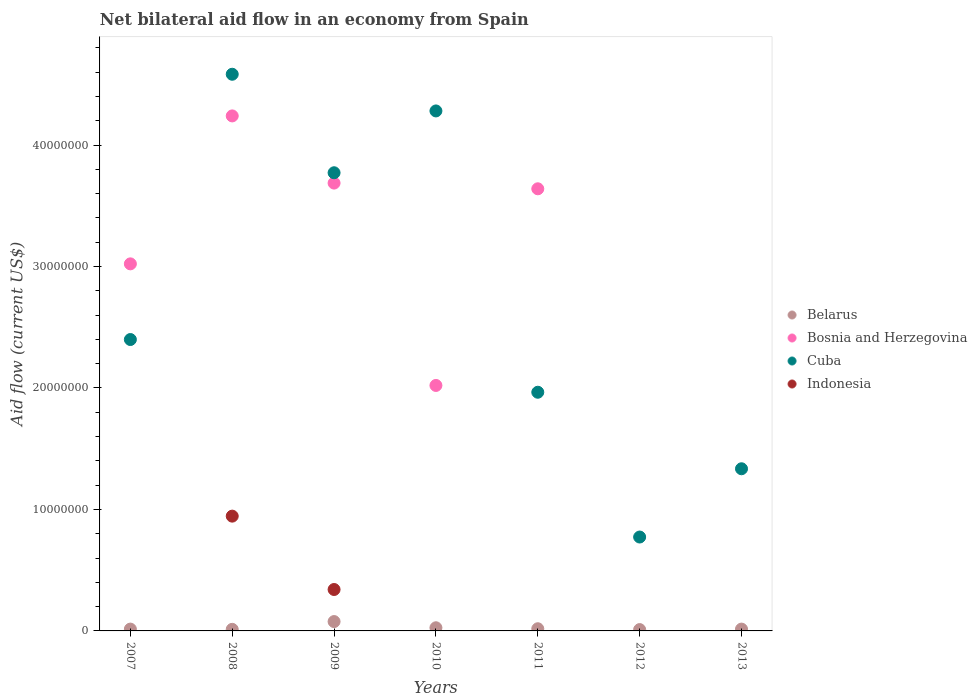Is the number of dotlines equal to the number of legend labels?
Provide a succinct answer. No. What is the net bilateral aid flow in Bosnia and Herzegovina in 2010?
Offer a very short reply. 2.02e+07. Across all years, what is the maximum net bilateral aid flow in Belarus?
Give a very brief answer. 7.70e+05. In which year was the net bilateral aid flow in Bosnia and Herzegovina maximum?
Give a very brief answer. 2008. What is the total net bilateral aid flow in Belarus in the graph?
Provide a succinct answer. 1.75e+06. What is the difference between the net bilateral aid flow in Belarus in 2010 and that in 2011?
Your answer should be compact. 8.00e+04. What is the difference between the net bilateral aid flow in Bosnia and Herzegovina in 2007 and the net bilateral aid flow in Belarus in 2010?
Offer a very short reply. 3.00e+07. What is the average net bilateral aid flow in Indonesia per year?
Your response must be concise. 1.84e+06. In the year 2009, what is the difference between the net bilateral aid flow in Bosnia and Herzegovina and net bilateral aid flow in Belarus?
Offer a very short reply. 3.61e+07. What is the ratio of the net bilateral aid flow in Bosnia and Herzegovina in 2008 to that in 2011?
Your answer should be very brief. 1.16. Is the net bilateral aid flow in Cuba in 2011 less than that in 2013?
Make the answer very short. No. What is the difference between the highest and the second highest net bilateral aid flow in Belarus?
Give a very brief answer. 5.10e+05. What is the difference between the highest and the lowest net bilateral aid flow in Belarus?
Make the answer very short. 6.60e+05. Is it the case that in every year, the sum of the net bilateral aid flow in Indonesia and net bilateral aid flow in Belarus  is greater than the sum of net bilateral aid flow in Bosnia and Herzegovina and net bilateral aid flow in Cuba?
Provide a short and direct response. No. Is it the case that in every year, the sum of the net bilateral aid flow in Belarus and net bilateral aid flow in Cuba  is greater than the net bilateral aid flow in Bosnia and Herzegovina?
Your answer should be compact. No. Is the net bilateral aid flow in Indonesia strictly greater than the net bilateral aid flow in Bosnia and Herzegovina over the years?
Make the answer very short. No. How many dotlines are there?
Keep it short and to the point. 4. How many legend labels are there?
Ensure brevity in your answer.  4. How are the legend labels stacked?
Your answer should be compact. Vertical. What is the title of the graph?
Make the answer very short. Net bilateral aid flow in an economy from Spain. What is the label or title of the X-axis?
Your answer should be very brief. Years. What is the label or title of the Y-axis?
Offer a terse response. Aid flow (current US$). What is the Aid flow (current US$) in Belarus in 2007?
Ensure brevity in your answer.  1.50e+05. What is the Aid flow (current US$) of Bosnia and Herzegovina in 2007?
Provide a succinct answer. 3.02e+07. What is the Aid flow (current US$) in Cuba in 2007?
Provide a short and direct response. 2.40e+07. What is the Aid flow (current US$) of Bosnia and Herzegovina in 2008?
Keep it short and to the point. 4.24e+07. What is the Aid flow (current US$) in Cuba in 2008?
Make the answer very short. 4.58e+07. What is the Aid flow (current US$) of Indonesia in 2008?
Your answer should be very brief. 9.45e+06. What is the Aid flow (current US$) in Belarus in 2009?
Ensure brevity in your answer.  7.70e+05. What is the Aid flow (current US$) in Bosnia and Herzegovina in 2009?
Your answer should be very brief. 3.69e+07. What is the Aid flow (current US$) in Cuba in 2009?
Ensure brevity in your answer.  3.77e+07. What is the Aid flow (current US$) of Indonesia in 2009?
Ensure brevity in your answer.  3.41e+06. What is the Aid flow (current US$) in Belarus in 2010?
Offer a terse response. 2.60e+05. What is the Aid flow (current US$) of Bosnia and Herzegovina in 2010?
Your answer should be compact. 2.02e+07. What is the Aid flow (current US$) of Cuba in 2010?
Your answer should be compact. 4.28e+07. What is the Aid flow (current US$) of Bosnia and Herzegovina in 2011?
Offer a very short reply. 3.64e+07. What is the Aid flow (current US$) in Cuba in 2011?
Offer a terse response. 1.96e+07. What is the Aid flow (current US$) of Belarus in 2012?
Provide a short and direct response. 1.10e+05. What is the Aid flow (current US$) of Cuba in 2012?
Ensure brevity in your answer.  7.73e+06. What is the Aid flow (current US$) in Indonesia in 2012?
Make the answer very short. 0. What is the Aid flow (current US$) of Belarus in 2013?
Provide a short and direct response. 1.50e+05. What is the Aid flow (current US$) in Bosnia and Herzegovina in 2013?
Your response must be concise. 0. What is the Aid flow (current US$) of Cuba in 2013?
Give a very brief answer. 1.34e+07. Across all years, what is the maximum Aid flow (current US$) in Belarus?
Your answer should be very brief. 7.70e+05. Across all years, what is the maximum Aid flow (current US$) of Bosnia and Herzegovina?
Make the answer very short. 4.24e+07. Across all years, what is the maximum Aid flow (current US$) in Cuba?
Provide a short and direct response. 4.58e+07. Across all years, what is the maximum Aid flow (current US$) of Indonesia?
Your answer should be compact. 9.45e+06. Across all years, what is the minimum Aid flow (current US$) of Bosnia and Herzegovina?
Provide a short and direct response. 0. Across all years, what is the minimum Aid flow (current US$) of Cuba?
Make the answer very short. 7.73e+06. Across all years, what is the minimum Aid flow (current US$) of Indonesia?
Ensure brevity in your answer.  0. What is the total Aid flow (current US$) of Belarus in the graph?
Your answer should be very brief. 1.75e+06. What is the total Aid flow (current US$) in Bosnia and Herzegovina in the graph?
Ensure brevity in your answer.  1.66e+08. What is the total Aid flow (current US$) of Cuba in the graph?
Your answer should be compact. 1.91e+08. What is the total Aid flow (current US$) of Indonesia in the graph?
Keep it short and to the point. 1.29e+07. What is the difference between the Aid flow (current US$) of Bosnia and Herzegovina in 2007 and that in 2008?
Give a very brief answer. -1.22e+07. What is the difference between the Aid flow (current US$) in Cuba in 2007 and that in 2008?
Ensure brevity in your answer.  -2.18e+07. What is the difference between the Aid flow (current US$) of Belarus in 2007 and that in 2009?
Make the answer very short. -6.20e+05. What is the difference between the Aid flow (current US$) of Bosnia and Herzegovina in 2007 and that in 2009?
Make the answer very short. -6.65e+06. What is the difference between the Aid flow (current US$) of Cuba in 2007 and that in 2009?
Provide a succinct answer. -1.37e+07. What is the difference between the Aid flow (current US$) of Bosnia and Herzegovina in 2007 and that in 2010?
Provide a short and direct response. 1.00e+07. What is the difference between the Aid flow (current US$) in Cuba in 2007 and that in 2010?
Offer a terse response. -1.88e+07. What is the difference between the Aid flow (current US$) of Bosnia and Herzegovina in 2007 and that in 2011?
Your answer should be compact. -6.18e+06. What is the difference between the Aid flow (current US$) of Cuba in 2007 and that in 2011?
Your answer should be very brief. 4.34e+06. What is the difference between the Aid flow (current US$) in Cuba in 2007 and that in 2012?
Offer a terse response. 1.63e+07. What is the difference between the Aid flow (current US$) of Belarus in 2007 and that in 2013?
Make the answer very short. 0. What is the difference between the Aid flow (current US$) in Cuba in 2007 and that in 2013?
Ensure brevity in your answer.  1.06e+07. What is the difference between the Aid flow (current US$) in Belarus in 2008 and that in 2009?
Offer a terse response. -6.40e+05. What is the difference between the Aid flow (current US$) in Bosnia and Herzegovina in 2008 and that in 2009?
Offer a very short reply. 5.53e+06. What is the difference between the Aid flow (current US$) in Cuba in 2008 and that in 2009?
Your answer should be very brief. 8.11e+06. What is the difference between the Aid flow (current US$) of Indonesia in 2008 and that in 2009?
Offer a terse response. 6.04e+06. What is the difference between the Aid flow (current US$) in Belarus in 2008 and that in 2010?
Offer a terse response. -1.30e+05. What is the difference between the Aid flow (current US$) in Bosnia and Herzegovina in 2008 and that in 2010?
Your answer should be compact. 2.22e+07. What is the difference between the Aid flow (current US$) in Cuba in 2008 and that in 2010?
Your answer should be very brief. 3.02e+06. What is the difference between the Aid flow (current US$) of Cuba in 2008 and that in 2011?
Offer a terse response. 2.62e+07. What is the difference between the Aid flow (current US$) in Belarus in 2008 and that in 2012?
Offer a terse response. 2.00e+04. What is the difference between the Aid flow (current US$) in Cuba in 2008 and that in 2012?
Your answer should be very brief. 3.81e+07. What is the difference between the Aid flow (current US$) of Cuba in 2008 and that in 2013?
Offer a terse response. 3.25e+07. What is the difference between the Aid flow (current US$) of Belarus in 2009 and that in 2010?
Provide a succinct answer. 5.10e+05. What is the difference between the Aid flow (current US$) of Bosnia and Herzegovina in 2009 and that in 2010?
Offer a terse response. 1.67e+07. What is the difference between the Aid flow (current US$) in Cuba in 2009 and that in 2010?
Make the answer very short. -5.09e+06. What is the difference between the Aid flow (current US$) in Belarus in 2009 and that in 2011?
Ensure brevity in your answer.  5.90e+05. What is the difference between the Aid flow (current US$) in Bosnia and Herzegovina in 2009 and that in 2011?
Your answer should be very brief. 4.70e+05. What is the difference between the Aid flow (current US$) in Cuba in 2009 and that in 2011?
Offer a terse response. 1.81e+07. What is the difference between the Aid flow (current US$) in Belarus in 2009 and that in 2012?
Keep it short and to the point. 6.60e+05. What is the difference between the Aid flow (current US$) in Cuba in 2009 and that in 2012?
Give a very brief answer. 3.00e+07. What is the difference between the Aid flow (current US$) of Belarus in 2009 and that in 2013?
Offer a very short reply. 6.20e+05. What is the difference between the Aid flow (current US$) of Cuba in 2009 and that in 2013?
Make the answer very short. 2.44e+07. What is the difference between the Aid flow (current US$) in Belarus in 2010 and that in 2011?
Give a very brief answer. 8.00e+04. What is the difference between the Aid flow (current US$) of Bosnia and Herzegovina in 2010 and that in 2011?
Provide a succinct answer. -1.62e+07. What is the difference between the Aid flow (current US$) of Cuba in 2010 and that in 2011?
Keep it short and to the point. 2.32e+07. What is the difference between the Aid flow (current US$) in Belarus in 2010 and that in 2012?
Make the answer very short. 1.50e+05. What is the difference between the Aid flow (current US$) in Cuba in 2010 and that in 2012?
Make the answer very short. 3.51e+07. What is the difference between the Aid flow (current US$) of Cuba in 2010 and that in 2013?
Give a very brief answer. 2.95e+07. What is the difference between the Aid flow (current US$) in Belarus in 2011 and that in 2012?
Your response must be concise. 7.00e+04. What is the difference between the Aid flow (current US$) of Cuba in 2011 and that in 2012?
Offer a very short reply. 1.19e+07. What is the difference between the Aid flow (current US$) in Belarus in 2011 and that in 2013?
Provide a succinct answer. 3.00e+04. What is the difference between the Aid flow (current US$) in Cuba in 2011 and that in 2013?
Keep it short and to the point. 6.30e+06. What is the difference between the Aid flow (current US$) of Belarus in 2012 and that in 2013?
Offer a terse response. -4.00e+04. What is the difference between the Aid flow (current US$) in Cuba in 2012 and that in 2013?
Your answer should be very brief. -5.62e+06. What is the difference between the Aid flow (current US$) of Belarus in 2007 and the Aid flow (current US$) of Bosnia and Herzegovina in 2008?
Ensure brevity in your answer.  -4.22e+07. What is the difference between the Aid flow (current US$) of Belarus in 2007 and the Aid flow (current US$) of Cuba in 2008?
Ensure brevity in your answer.  -4.57e+07. What is the difference between the Aid flow (current US$) in Belarus in 2007 and the Aid flow (current US$) in Indonesia in 2008?
Your answer should be very brief. -9.30e+06. What is the difference between the Aid flow (current US$) in Bosnia and Herzegovina in 2007 and the Aid flow (current US$) in Cuba in 2008?
Your answer should be very brief. -1.56e+07. What is the difference between the Aid flow (current US$) of Bosnia and Herzegovina in 2007 and the Aid flow (current US$) of Indonesia in 2008?
Ensure brevity in your answer.  2.08e+07. What is the difference between the Aid flow (current US$) in Cuba in 2007 and the Aid flow (current US$) in Indonesia in 2008?
Your answer should be compact. 1.45e+07. What is the difference between the Aid flow (current US$) of Belarus in 2007 and the Aid flow (current US$) of Bosnia and Herzegovina in 2009?
Provide a succinct answer. -3.67e+07. What is the difference between the Aid flow (current US$) of Belarus in 2007 and the Aid flow (current US$) of Cuba in 2009?
Offer a very short reply. -3.76e+07. What is the difference between the Aid flow (current US$) in Belarus in 2007 and the Aid flow (current US$) in Indonesia in 2009?
Your answer should be very brief. -3.26e+06. What is the difference between the Aid flow (current US$) in Bosnia and Herzegovina in 2007 and the Aid flow (current US$) in Cuba in 2009?
Your answer should be very brief. -7.50e+06. What is the difference between the Aid flow (current US$) in Bosnia and Herzegovina in 2007 and the Aid flow (current US$) in Indonesia in 2009?
Offer a terse response. 2.68e+07. What is the difference between the Aid flow (current US$) of Cuba in 2007 and the Aid flow (current US$) of Indonesia in 2009?
Provide a short and direct response. 2.06e+07. What is the difference between the Aid flow (current US$) of Belarus in 2007 and the Aid flow (current US$) of Bosnia and Herzegovina in 2010?
Provide a short and direct response. -2.01e+07. What is the difference between the Aid flow (current US$) in Belarus in 2007 and the Aid flow (current US$) in Cuba in 2010?
Make the answer very short. -4.27e+07. What is the difference between the Aid flow (current US$) in Bosnia and Herzegovina in 2007 and the Aid flow (current US$) in Cuba in 2010?
Give a very brief answer. -1.26e+07. What is the difference between the Aid flow (current US$) of Belarus in 2007 and the Aid flow (current US$) of Bosnia and Herzegovina in 2011?
Make the answer very short. -3.62e+07. What is the difference between the Aid flow (current US$) of Belarus in 2007 and the Aid flow (current US$) of Cuba in 2011?
Give a very brief answer. -1.95e+07. What is the difference between the Aid flow (current US$) of Bosnia and Herzegovina in 2007 and the Aid flow (current US$) of Cuba in 2011?
Offer a terse response. 1.06e+07. What is the difference between the Aid flow (current US$) in Belarus in 2007 and the Aid flow (current US$) in Cuba in 2012?
Offer a very short reply. -7.58e+06. What is the difference between the Aid flow (current US$) of Bosnia and Herzegovina in 2007 and the Aid flow (current US$) of Cuba in 2012?
Provide a short and direct response. 2.25e+07. What is the difference between the Aid flow (current US$) of Belarus in 2007 and the Aid flow (current US$) of Cuba in 2013?
Offer a very short reply. -1.32e+07. What is the difference between the Aid flow (current US$) of Bosnia and Herzegovina in 2007 and the Aid flow (current US$) of Cuba in 2013?
Your answer should be very brief. 1.69e+07. What is the difference between the Aid flow (current US$) of Belarus in 2008 and the Aid flow (current US$) of Bosnia and Herzegovina in 2009?
Make the answer very short. -3.67e+07. What is the difference between the Aid flow (current US$) in Belarus in 2008 and the Aid flow (current US$) in Cuba in 2009?
Offer a terse response. -3.76e+07. What is the difference between the Aid flow (current US$) in Belarus in 2008 and the Aid flow (current US$) in Indonesia in 2009?
Provide a succinct answer. -3.28e+06. What is the difference between the Aid flow (current US$) of Bosnia and Herzegovina in 2008 and the Aid flow (current US$) of Cuba in 2009?
Provide a succinct answer. 4.68e+06. What is the difference between the Aid flow (current US$) in Bosnia and Herzegovina in 2008 and the Aid flow (current US$) in Indonesia in 2009?
Offer a very short reply. 3.90e+07. What is the difference between the Aid flow (current US$) of Cuba in 2008 and the Aid flow (current US$) of Indonesia in 2009?
Give a very brief answer. 4.24e+07. What is the difference between the Aid flow (current US$) of Belarus in 2008 and the Aid flow (current US$) of Bosnia and Herzegovina in 2010?
Your answer should be compact. -2.01e+07. What is the difference between the Aid flow (current US$) of Belarus in 2008 and the Aid flow (current US$) of Cuba in 2010?
Offer a terse response. -4.27e+07. What is the difference between the Aid flow (current US$) in Bosnia and Herzegovina in 2008 and the Aid flow (current US$) in Cuba in 2010?
Provide a succinct answer. -4.10e+05. What is the difference between the Aid flow (current US$) in Belarus in 2008 and the Aid flow (current US$) in Bosnia and Herzegovina in 2011?
Offer a terse response. -3.63e+07. What is the difference between the Aid flow (current US$) of Belarus in 2008 and the Aid flow (current US$) of Cuba in 2011?
Offer a terse response. -1.95e+07. What is the difference between the Aid flow (current US$) of Bosnia and Herzegovina in 2008 and the Aid flow (current US$) of Cuba in 2011?
Ensure brevity in your answer.  2.28e+07. What is the difference between the Aid flow (current US$) in Belarus in 2008 and the Aid flow (current US$) in Cuba in 2012?
Offer a terse response. -7.60e+06. What is the difference between the Aid flow (current US$) of Bosnia and Herzegovina in 2008 and the Aid flow (current US$) of Cuba in 2012?
Make the answer very short. 3.47e+07. What is the difference between the Aid flow (current US$) of Belarus in 2008 and the Aid flow (current US$) of Cuba in 2013?
Offer a terse response. -1.32e+07. What is the difference between the Aid flow (current US$) in Bosnia and Herzegovina in 2008 and the Aid flow (current US$) in Cuba in 2013?
Ensure brevity in your answer.  2.90e+07. What is the difference between the Aid flow (current US$) of Belarus in 2009 and the Aid flow (current US$) of Bosnia and Herzegovina in 2010?
Your response must be concise. -1.94e+07. What is the difference between the Aid flow (current US$) of Belarus in 2009 and the Aid flow (current US$) of Cuba in 2010?
Your answer should be compact. -4.20e+07. What is the difference between the Aid flow (current US$) in Bosnia and Herzegovina in 2009 and the Aid flow (current US$) in Cuba in 2010?
Make the answer very short. -5.94e+06. What is the difference between the Aid flow (current US$) in Belarus in 2009 and the Aid flow (current US$) in Bosnia and Herzegovina in 2011?
Your response must be concise. -3.56e+07. What is the difference between the Aid flow (current US$) in Belarus in 2009 and the Aid flow (current US$) in Cuba in 2011?
Provide a succinct answer. -1.89e+07. What is the difference between the Aid flow (current US$) of Bosnia and Herzegovina in 2009 and the Aid flow (current US$) of Cuba in 2011?
Give a very brief answer. 1.72e+07. What is the difference between the Aid flow (current US$) of Belarus in 2009 and the Aid flow (current US$) of Cuba in 2012?
Your answer should be compact. -6.96e+06. What is the difference between the Aid flow (current US$) of Bosnia and Herzegovina in 2009 and the Aid flow (current US$) of Cuba in 2012?
Ensure brevity in your answer.  2.91e+07. What is the difference between the Aid flow (current US$) of Belarus in 2009 and the Aid flow (current US$) of Cuba in 2013?
Provide a short and direct response. -1.26e+07. What is the difference between the Aid flow (current US$) in Bosnia and Herzegovina in 2009 and the Aid flow (current US$) in Cuba in 2013?
Keep it short and to the point. 2.35e+07. What is the difference between the Aid flow (current US$) of Belarus in 2010 and the Aid flow (current US$) of Bosnia and Herzegovina in 2011?
Ensure brevity in your answer.  -3.61e+07. What is the difference between the Aid flow (current US$) in Belarus in 2010 and the Aid flow (current US$) in Cuba in 2011?
Your response must be concise. -1.94e+07. What is the difference between the Aid flow (current US$) of Bosnia and Herzegovina in 2010 and the Aid flow (current US$) of Cuba in 2011?
Keep it short and to the point. 5.60e+05. What is the difference between the Aid flow (current US$) in Belarus in 2010 and the Aid flow (current US$) in Cuba in 2012?
Your answer should be very brief. -7.47e+06. What is the difference between the Aid flow (current US$) in Bosnia and Herzegovina in 2010 and the Aid flow (current US$) in Cuba in 2012?
Provide a succinct answer. 1.25e+07. What is the difference between the Aid flow (current US$) in Belarus in 2010 and the Aid flow (current US$) in Cuba in 2013?
Your response must be concise. -1.31e+07. What is the difference between the Aid flow (current US$) in Bosnia and Herzegovina in 2010 and the Aid flow (current US$) in Cuba in 2013?
Your answer should be very brief. 6.86e+06. What is the difference between the Aid flow (current US$) of Belarus in 2011 and the Aid flow (current US$) of Cuba in 2012?
Ensure brevity in your answer.  -7.55e+06. What is the difference between the Aid flow (current US$) in Bosnia and Herzegovina in 2011 and the Aid flow (current US$) in Cuba in 2012?
Offer a terse response. 2.87e+07. What is the difference between the Aid flow (current US$) in Belarus in 2011 and the Aid flow (current US$) in Cuba in 2013?
Your answer should be compact. -1.32e+07. What is the difference between the Aid flow (current US$) in Bosnia and Herzegovina in 2011 and the Aid flow (current US$) in Cuba in 2013?
Give a very brief answer. 2.30e+07. What is the difference between the Aid flow (current US$) in Belarus in 2012 and the Aid flow (current US$) in Cuba in 2013?
Provide a short and direct response. -1.32e+07. What is the average Aid flow (current US$) in Bosnia and Herzegovina per year?
Your response must be concise. 2.37e+07. What is the average Aid flow (current US$) of Cuba per year?
Your answer should be very brief. 2.73e+07. What is the average Aid flow (current US$) in Indonesia per year?
Make the answer very short. 1.84e+06. In the year 2007, what is the difference between the Aid flow (current US$) in Belarus and Aid flow (current US$) in Bosnia and Herzegovina?
Your response must be concise. -3.01e+07. In the year 2007, what is the difference between the Aid flow (current US$) of Belarus and Aid flow (current US$) of Cuba?
Make the answer very short. -2.38e+07. In the year 2007, what is the difference between the Aid flow (current US$) of Bosnia and Herzegovina and Aid flow (current US$) of Cuba?
Your answer should be compact. 6.23e+06. In the year 2008, what is the difference between the Aid flow (current US$) of Belarus and Aid flow (current US$) of Bosnia and Herzegovina?
Make the answer very short. -4.23e+07. In the year 2008, what is the difference between the Aid flow (current US$) of Belarus and Aid flow (current US$) of Cuba?
Your answer should be very brief. -4.57e+07. In the year 2008, what is the difference between the Aid flow (current US$) in Belarus and Aid flow (current US$) in Indonesia?
Give a very brief answer. -9.32e+06. In the year 2008, what is the difference between the Aid flow (current US$) of Bosnia and Herzegovina and Aid flow (current US$) of Cuba?
Offer a very short reply. -3.43e+06. In the year 2008, what is the difference between the Aid flow (current US$) of Bosnia and Herzegovina and Aid flow (current US$) of Indonesia?
Make the answer very short. 3.30e+07. In the year 2008, what is the difference between the Aid flow (current US$) in Cuba and Aid flow (current US$) in Indonesia?
Your response must be concise. 3.64e+07. In the year 2009, what is the difference between the Aid flow (current US$) of Belarus and Aid flow (current US$) of Bosnia and Herzegovina?
Provide a succinct answer. -3.61e+07. In the year 2009, what is the difference between the Aid flow (current US$) in Belarus and Aid flow (current US$) in Cuba?
Your response must be concise. -3.70e+07. In the year 2009, what is the difference between the Aid flow (current US$) in Belarus and Aid flow (current US$) in Indonesia?
Make the answer very short. -2.64e+06. In the year 2009, what is the difference between the Aid flow (current US$) of Bosnia and Herzegovina and Aid flow (current US$) of Cuba?
Make the answer very short. -8.50e+05. In the year 2009, what is the difference between the Aid flow (current US$) of Bosnia and Herzegovina and Aid flow (current US$) of Indonesia?
Ensure brevity in your answer.  3.35e+07. In the year 2009, what is the difference between the Aid flow (current US$) in Cuba and Aid flow (current US$) in Indonesia?
Provide a succinct answer. 3.43e+07. In the year 2010, what is the difference between the Aid flow (current US$) of Belarus and Aid flow (current US$) of Bosnia and Herzegovina?
Provide a succinct answer. -2.00e+07. In the year 2010, what is the difference between the Aid flow (current US$) in Belarus and Aid flow (current US$) in Cuba?
Offer a terse response. -4.26e+07. In the year 2010, what is the difference between the Aid flow (current US$) of Bosnia and Herzegovina and Aid flow (current US$) of Cuba?
Offer a very short reply. -2.26e+07. In the year 2011, what is the difference between the Aid flow (current US$) of Belarus and Aid flow (current US$) of Bosnia and Herzegovina?
Provide a succinct answer. -3.62e+07. In the year 2011, what is the difference between the Aid flow (current US$) of Belarus and Aid flow (current US$) of Cuba?
Ensure brevity in your answer.  -1.95e+07. In the year 2011, what is the difference between the Aid flow (current US$) in Bosnia and Herzegovina and Aid flow (current US$) in Cuba?
Provide a succinct answer. 1.68e+07. In the year 2012, what is the difference between the Aid flow (current US$) of Belarus and Aid flow (current US$) of Cuba?
Keep it short and to the point. -7.62e+06. In the year 2013, what is the difference between the Aid flow (current US$) of Belarus and Aid flow (current US$) of Cuba?
Provide a succinct answer. -1.32e+07. What is the ratio of the Aid flow (current US$) in Belarus in 2007 to that in 2008?
Keep it short and to the point. 1.15. What is the ratio of the Aid flow (current US$) of Bosnia and Herzegovina in 2007 to that in 2008?
Provide a succinct answer. 0.71. What is the ratio of the Aid flow (current US$) of Cuba in 2007 to that in 2008?
Your response must be concise. 0.52. What is the ratio of the Aid flow (current US$) of Belarus in 2007 to that in 2009?
Give a very brief answer. 0.19. What is the ratio of the Aid flow (current US$) in Bosnia and Herzegovina in 2007 to that in 2009?
Keep it short and to the point. 0.82. What is the ratio of the Aid flow (current US$) in Cuba in 2007 to that in 2009?
Give a very brief answer. 0.64. What is the ratio of the Aid flow (current US$) in Belarus in 2007 to that in 2010?
Offer a very short reply. 0.58. What is the ratio of the Aid flow (current US$) of Bosnia and Herzegovina in 2007 to that in 2010?
Provide a succinct answer. 1.5. What is the ratio of the Aid flow (current US$) in Cuba in 2007 to that in 2010?
Offer a very short reply. 0.56. What is the ratio of the Aid flow (current US$) in Bosnia and Herzegovina in 2007 to that in 2011?
Offer a terse response. 0.83. What is the ratio of the Aid flow (current US$) in Cuba in 2007 to that in 2011?
Keep it short and to the point. 1.22. What is the ratio of the Aid flow (current US$) of Belarus in 2007 to that in 2012?
Ensure brevity in your answer.  1.36. What is the ratio of the Aid flow (current US$) of Cuba in 2007 to that in 2012?
Your answer should be very brief. 3.1. What is the ratio of the Aid flow (current US$) of Cuba in 2007 to that in 2013?
Ensure brevity in your answer.  1.8. What is the ratio of the Aid flow (current US$) in Belarus in 2008 to that in 2009?
Keep it short and to the point. 0.17. What is the ratio of the Aid flow (current US$) of Bosnia and Herzegovina in 2008 to that in 2009?
Give a very brief answer. 1.15. What is the ratio of the Aid flow (current US$) of Cuba in 2008 to that in 2009?
Your response must be concise. 1.22. What is the ratio of the Aid flow (current US$) in Indonesia in 2008 to that in 2009?
Your answer should be compact. 2.77. What is the ratio of the Aid flow (current US$) of Belarus in 2008 to that in 2010?
Provide a succinct answer. 0.5. What is the ratio of the Aid flow (current US$) of Bosnia and Herzegovina in 2008 to that in 2010?
Your response must be concise. 2.1. What is the ratio of the Aid flow (current US$) in Cuba in 2008 to that in 2010?
Your response must be concise. 1.07. What is the ratio of the Aid flow (current US$) of Belarus in 2008 to that in 2011?
Your answer should be compact. 0.72. What is the ratio of the Aid flow (current US$) in Bosnia and Herzegovina in 2008 to that in 2011?
Keep it short and to the point. 1.16. What is the ratio of the Aid flow (current US$) of Cuba in 2008 to that in 2011?
Your answer should be very brief. 2.33. What is the ratio of the Aid flow (current US$) of Belarus in 2008 to that in 2012?
Give a very brief answer. 1.18. What is the ratio of the Aid flow (current US$) in Cuba in 2008 to that in 2012?
Your answer should be compact. 5.93. What is the ratio of the Aid flow (current US$) in Belarus in 2008 to that in 2013?
Provide a succinct answer. 0.87. What is the ratio of the Aid flow (current US$) of Cuba in 2008 to that in 2013?
Your answer should be very brief. 3.43. What is the ratio of the Aid flow (current US$) of Belarus in 2009 to that in 2010?
Provide a short and direct response. 2.96. What is the ratio of the Aid flow (current US$) of Bosnia and Herzegovina in 2009 to that in 2010?
Keep it short and to the point. 1.82. What is the ratio of the Aid flow (current US$) of Cuba in 2009 to that in 2010?
Your answer should be very brief. 0.88. What is the ratio of the Aid flow (current US$) of Belarus in 2009 to that in 2011?
Provide a short and direct response. 4.28. What is the ratio of the Aid flow (current US$) of Bosnia and Herzegovina in 2009 to that in 2011?
Offer a terse response. 1.01. What is the ratio of the Aid flow (current US$) in Cuba in 2009 to that in 2011?
Offer a very short reply. 1.92. What is the ratio of the Aid flow (current US$) of Cuba in 2009 to that in 2012?
Keep it short and to the point. 4.88. What is the ratio of the Aid flow (current US$) of Belarus in 2009 to that in 2013?
Your response must be concise. 5.13. What is the ratio of the Aid flow (current US$) in Cuba in 2009 to that in 2013?
Ensure brevity in your answer.  2.83. What is the ratio of the Aid flow (current US$) in Belarus in 2010 to that in 2011?
Provide a succinct answer. 1.44. What is the ratio of the Aid flow (current US$) of Bosnia and Herzegovina in 2010 to that in 2011?
Your response must be concise. 0.56. What is the ratio of the Aid flow (current US$) in Cuba in 2010 to that in 2011?
Keep it short and to the point. 2.18. What is the ratio of the Aid flow (current US$) in Belarus in 2010 to that in 2012?
Ensure brevity in your answer.  2.36. What is the ratio of the Aid flow (current US$) of Cuba in 2010 to that in 2012?
Offer a terse response. 5.54. What is the ratio of the Aid flow (current US$) in Belarus in 2010 to that in 2013?
Ensure brevity in your answer.  1.73. What is the ratio of the Aid flow (current US$) of Cuba in 2010 to that in 2013?
Give a very brief answer. 3.21. What is the ratio of the Aid flow (current US$) in Belarus in 2011 to that in 2012?
Provide a succinct answer. 1.64. What is the ratio of the Aid flow (current US$) in Cuba in 2011 to that in 2012?
Your answer should be compact. 2.54. What is the ratio of the Aid flow (current US$) in Cuba in 2011 to that in 2013?
Your response must be concise. 1.47. What is the ratio of the Aid flow (current US$) of Belarus in 2012 to that in 2013?
Offer a terse response. 0.73. What is the ratio of the Aid flow (current US$) of Cuba in 2012 to that in 2013?
Provide a succinct answer. 0.58. What is the difference between the highest and the second highest Aid flow (current US$) in Belarus?
Your response must be concise. 5.10e+05. What is the difference between the highest and the second highest Aid flow (current US$) of Bosnia and Herzegovina?
Ensure brevity in your answer.  5.53e+06. What is the difference between the highest and the second highest Aid flow (current US$) of Cuba?
Ensure brevity in your answer.  3.02e+06. What is the difference between the highest and the lowest Aid flow (current US$) in Bosnia and Herzegovina?
Offer a terse response. 4.24e+07. What is the difference between the highest and the lowest Aid flow (current US$) in Cuba?
Offer a terse response. 3.81e+07. What is the difference between the highest and the lowest Aid flow (current US$) in Indonesia?
Ensure brevity in your answer.  9.45e+06. 